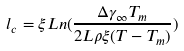Convert formula to latex. <formula><loc_0><loc_0><loc_500><loc_500>l _ { c } = \xi L n ( \frac { \Delta \gamma _ { \infty } T _ { m } } { 2 L \rho \xi ( T - T _ { m } ) } )</formula> 